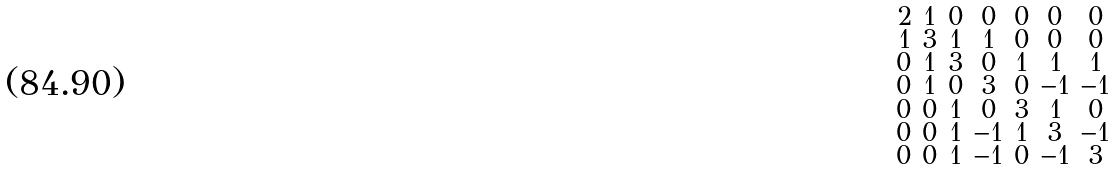Convert formula to latex. <formula><loc_0><loc_0><loc_500><loc_500>\begin{smallmatrix} 2 & 1 & 0 & 0 & 0 & 0 & 0 \\ 1 & 3 & 1 & 1 & 0 & 0 & 0 \\ 0 & 1 & 3 & 0 & 1 & 1 & 1 \\ 0 & 1 & 0 & 3 & 0 & - 1 & - 1 \\ 0 & 0 & 1 & 0 & 3 & 1 & 0 \\ 0 & 0 & 1 & - 1 & 1 & 3 & - 1 \\ 0 & 0 & 1 & - 1 & 0 & - 1 & 3 \end{smallmatrix}</formula> 